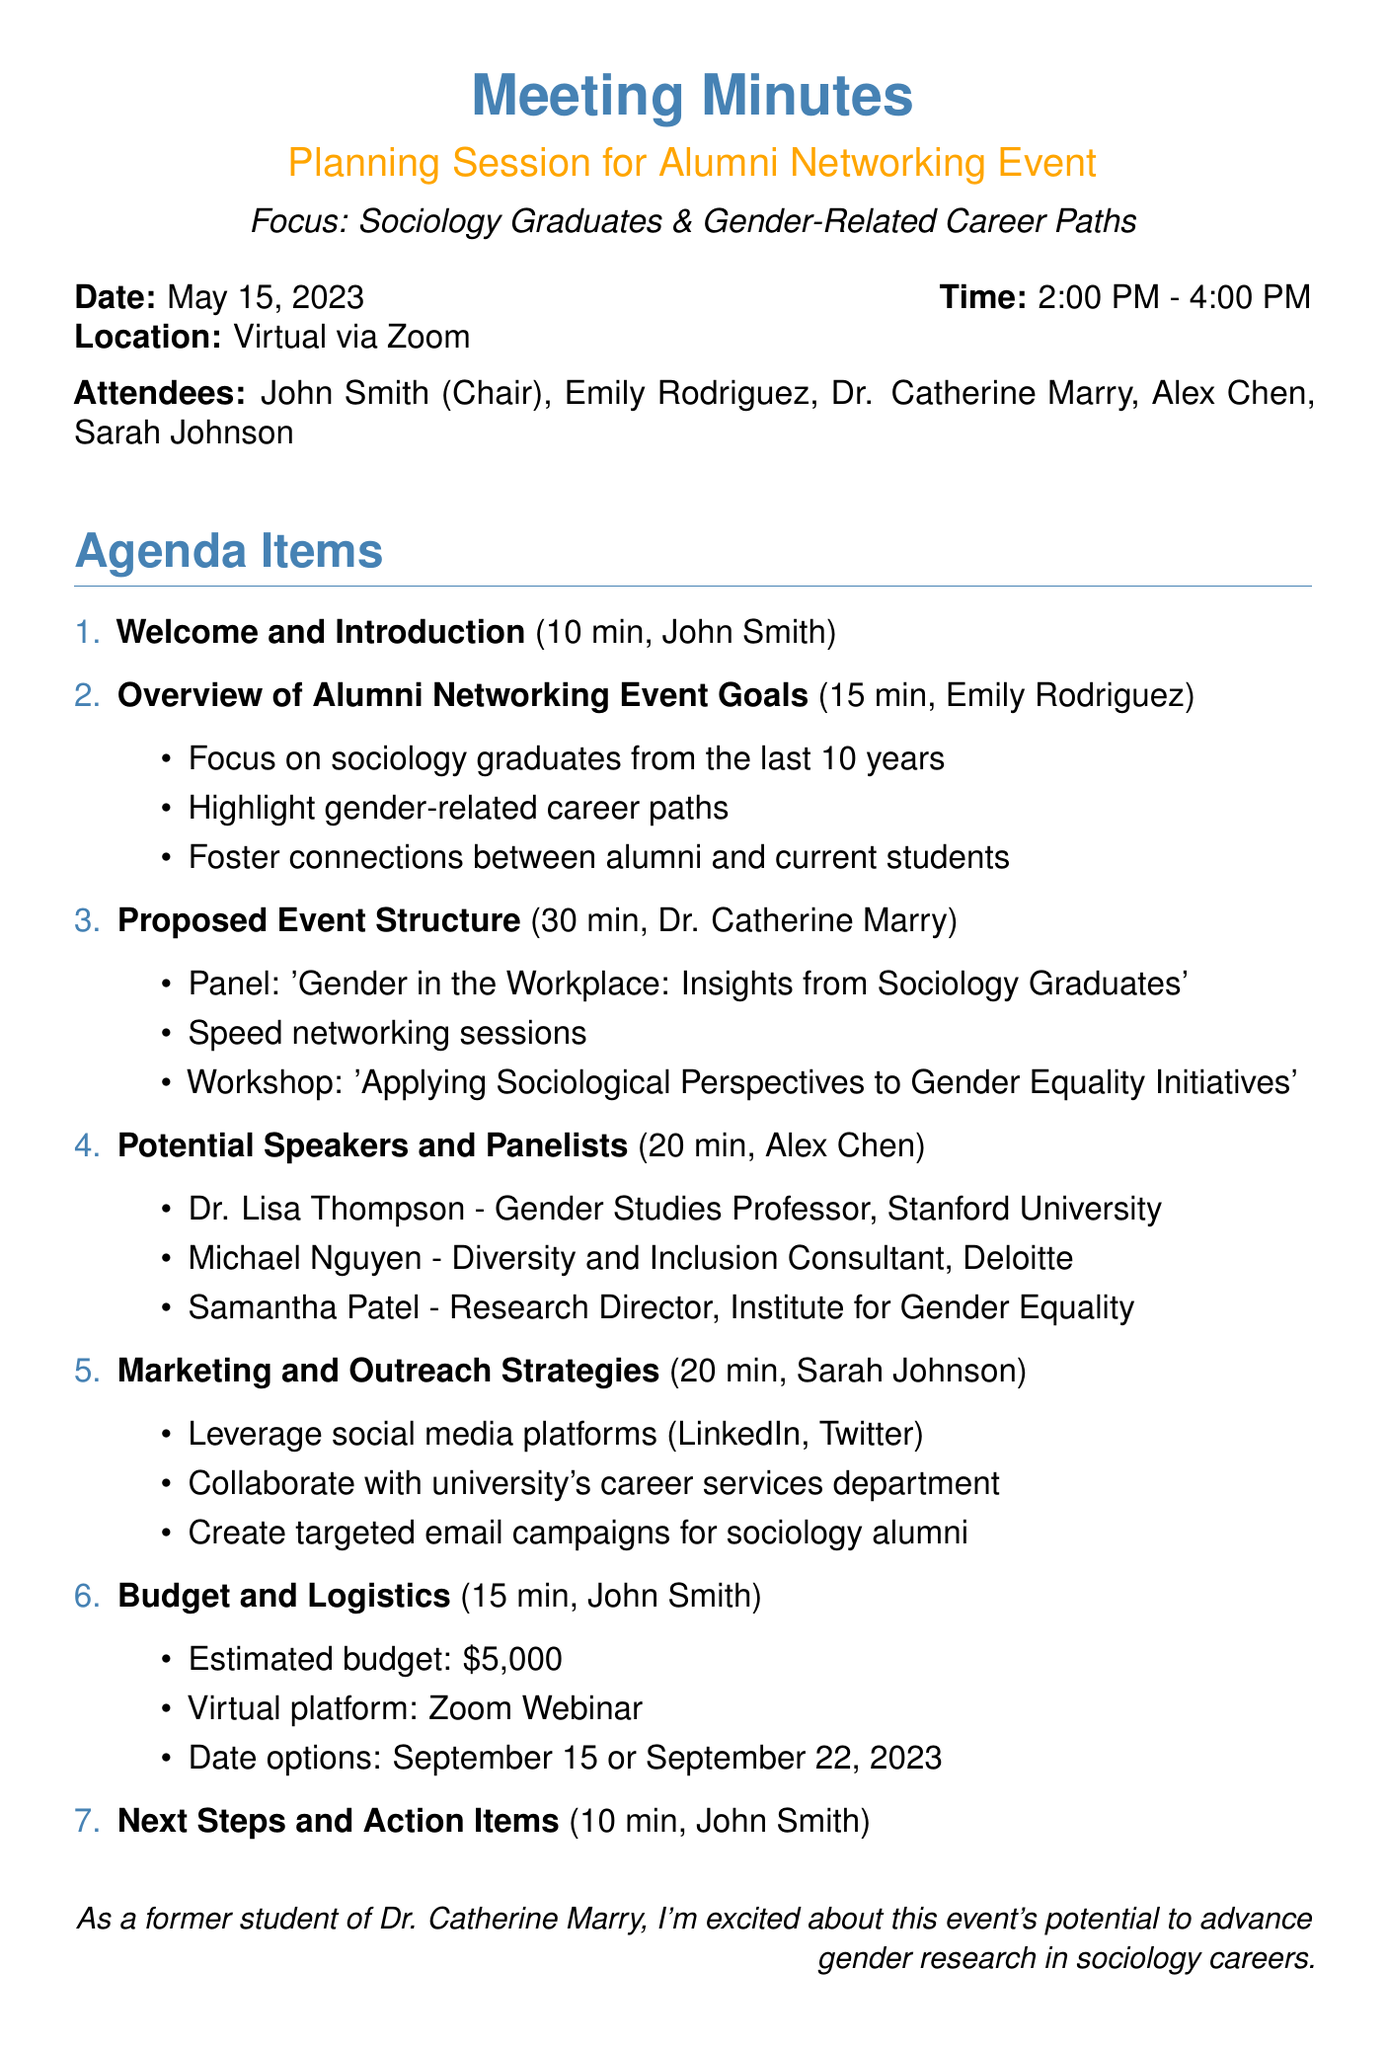What is the date of the meeting? The date of the meeting is explicitly mentioned at the beginning of the document.
Answer: May 15, 2023 Who is the presenter for the Proposed Event Structure? The presenter for this agenda item is specified under the Proposed Event Structure.
Answer: Dr. Catherine Marry What is the estimated budget for the event? The estimated budget is clearly stated in the Budget and Logistics section of the document.
Answer: $5,000 How long is the Overview of Alumni Networking Event Goals scheduled for? The duration for this agenda item is noted in the respective section of the document.
Answer: 15 minutes Which social media platforms are recommended for outreach? The specific platforms are listed under the Marketing and Outreach Strategies section.
Answer: LinkedIn, Twitter What are the two date options for the event? The two date options are provided in the Budget and Logistics section.
Answer: September 15 or September 22, 2023 Name one suggested speaker for the event. Suggested speakers are listed in the Potential Speakers and Panelists section of the document.
Answer: Dr. Lisa Thompson What type of event structure is proposed to include a workshop? The event structure mentions specific activities, including workshops, in the Proposed Event Structure section.
Answer: 'Applying Sociological Perspectives to Gender Equality Initiatives' What is the main focus of the alumni networking event? The main focus is highlighted in the Overview of Alumni Networking Event Goals section.
Answer: Gender-related career paths 